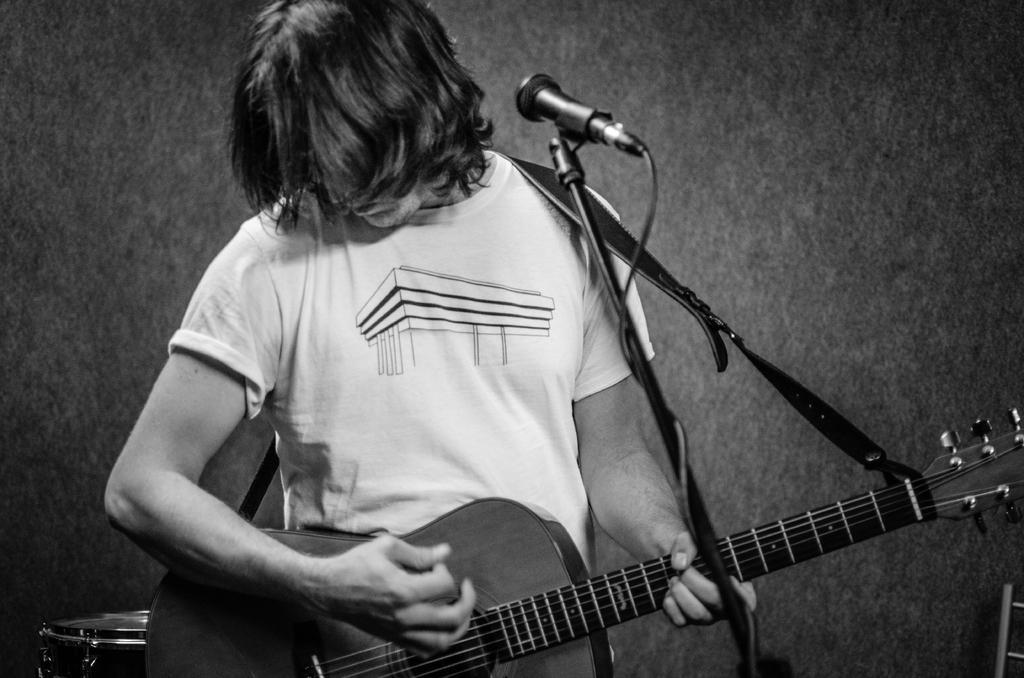How would you summarize this image in a sentence or two? In this black and white picture we can see a man with short hair standing in front of a mike and playing guitar. 